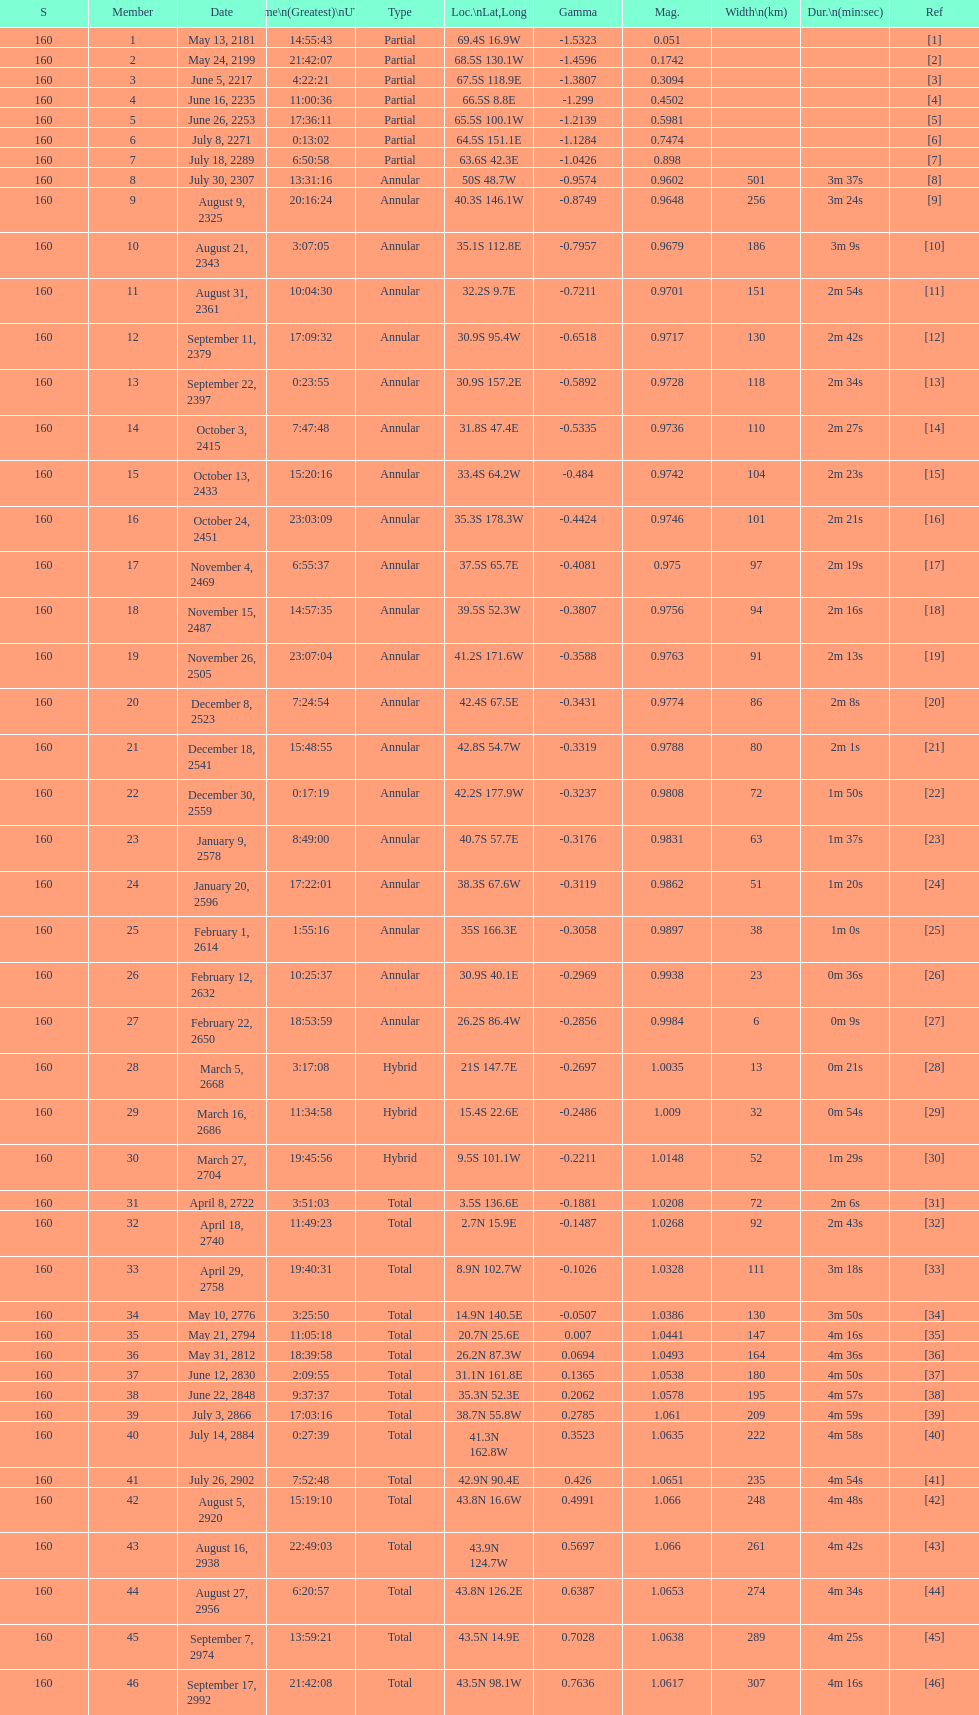How long did 18 last? 2m 16s. 